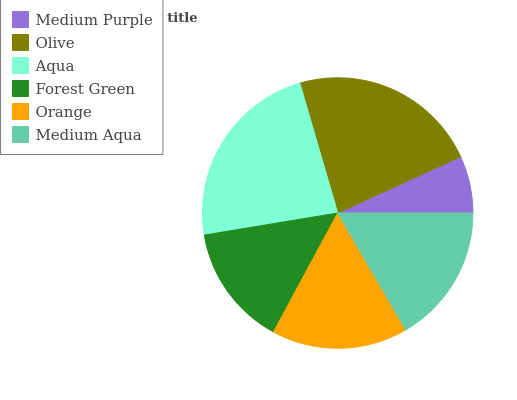Is Medium Purple the minimum?
Answer yes or no. Yes. Is Aqua the maximum?
Answer yes or no. Yes. Is Olive the minimum?
Answer yes or no. No. Is Olive the maximum?
Answer yes or no. No. Is Olive greater than Medium Purple?
Answer yes or no. Yes. Is Medium Purple less than Olive?
Answer yes or no. Yes. Is Medium Purple greater than Olive?
Answer yes or no. No. Is Olive less than Medium Purple?
Answer yes or no. No. Is Medium Aqua the high median?
Answer yes or no. Yes. Is Orange the low median?
Answer yes or no. Yes. Is Forest Green the high median?
Answer yes or no. No. Is Forest Green the low median?
Answer yes or no. No. 